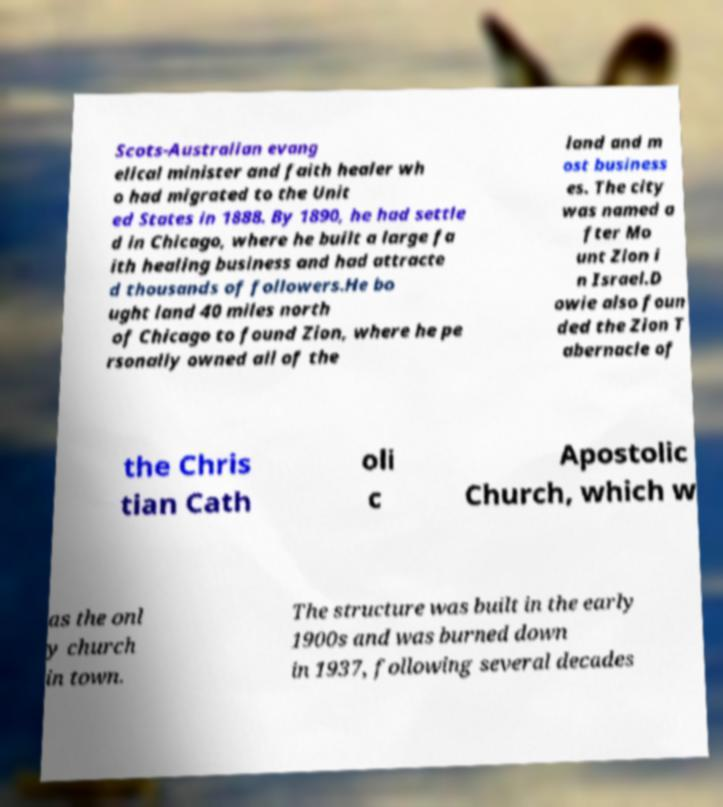What messages or text are displayed in this image? I need them in a readable, typed format. Scots-Australian evang elical minister and faith healer wh o had migrated to the Unit ed States in 1888. By 1890, he had settle d in Chicago, where he built a large fa ith healing business and had attracte d thousands of followers.He bo ught land 40 miles north of Chicago to found Zion, where he pe rsonally owned all of the land and m ost business es. The city was named a fter Mo unt Zion i n Israel.D owie also foun ded the Zion T abernacle of the Chris tian Cath oli c Apostolic Church, which w as the onl y church in town. The structure was built in the early 1900s and was burned down in 1937, following several decades 